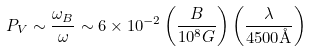Convert formula to latex. <formula><loc_0><loc_0><loc_500><loc_500>P _ { V } \sim \frac { \omega _ { B } } { \omega } \sim 6 \times 1 0 ^ { - 2 } \left ( \frac { B } { 1 0 ^ { 8 } G } \right ) \left ( \frac { \lambda } { 4 5 0 0 \AA } \right )</formula> 